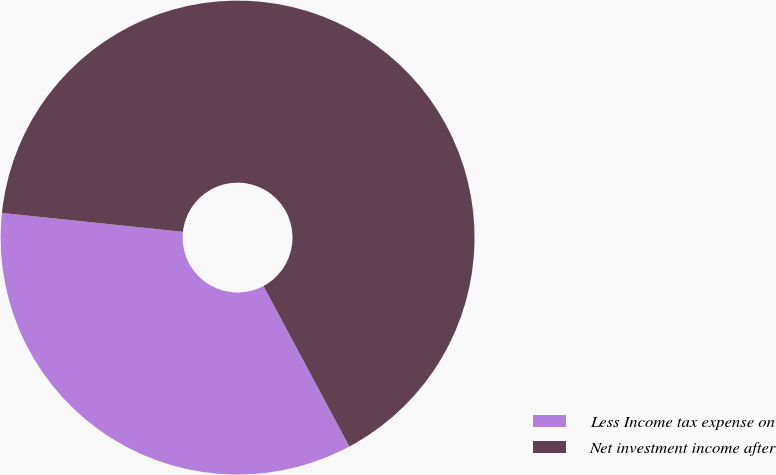Convert chart. <chart><loc_0><loc_0><loc_500><loc_500><pie_chart><fcel>Less Income tax expense on<fcel>Net investment income after<nl><fcel>34.48%<fcel>65.52%<nl></chart> 